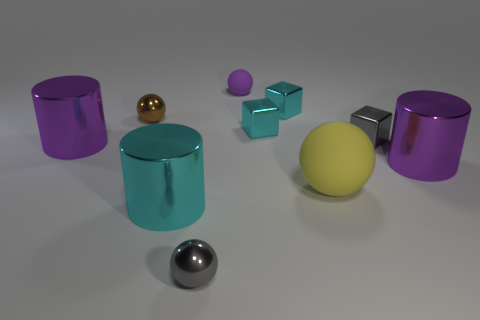Do the big cyan cylinder and the small brown ball have the same material?
Offer a terse response. Yes. How many metal blocks are in front of the purple cylinder that is to the right of the big rubber object?
Keep it short and to the point. 0. How many matte things are both to the left of the large yellow rubber ball and in front of the small brown thing?
Provide a short and direct response. 0. What number of objects are either big yellow rubber objects or spheres in front of the gray cube?
Give a very brief answer. 2. There is a thing that is the same material as the large sphere; what is its size?
Keep it short and to the point. Small. There is a cyan thing in front of the purple cylinder that is on the right side of the tiny purple sphere; what shape is it?
Make the answer very short. Cylinder. What number of yellow things are either tiny matte objects or tiny things?
Your answer should be compact. 0. There is a small metallic ball in front of the metallic cylinder to the left of the brown shiny ball; are there any brown things that are behind it?
Your answer should be compact. Yes. How many large things are either red metallic cylinders or brown balls?
Provide a succinct answer. 0. There is a tiny matte thing that is behind the gray block; is it the same shape as the brown metallic object?
Give a very brief answer. Yes. 